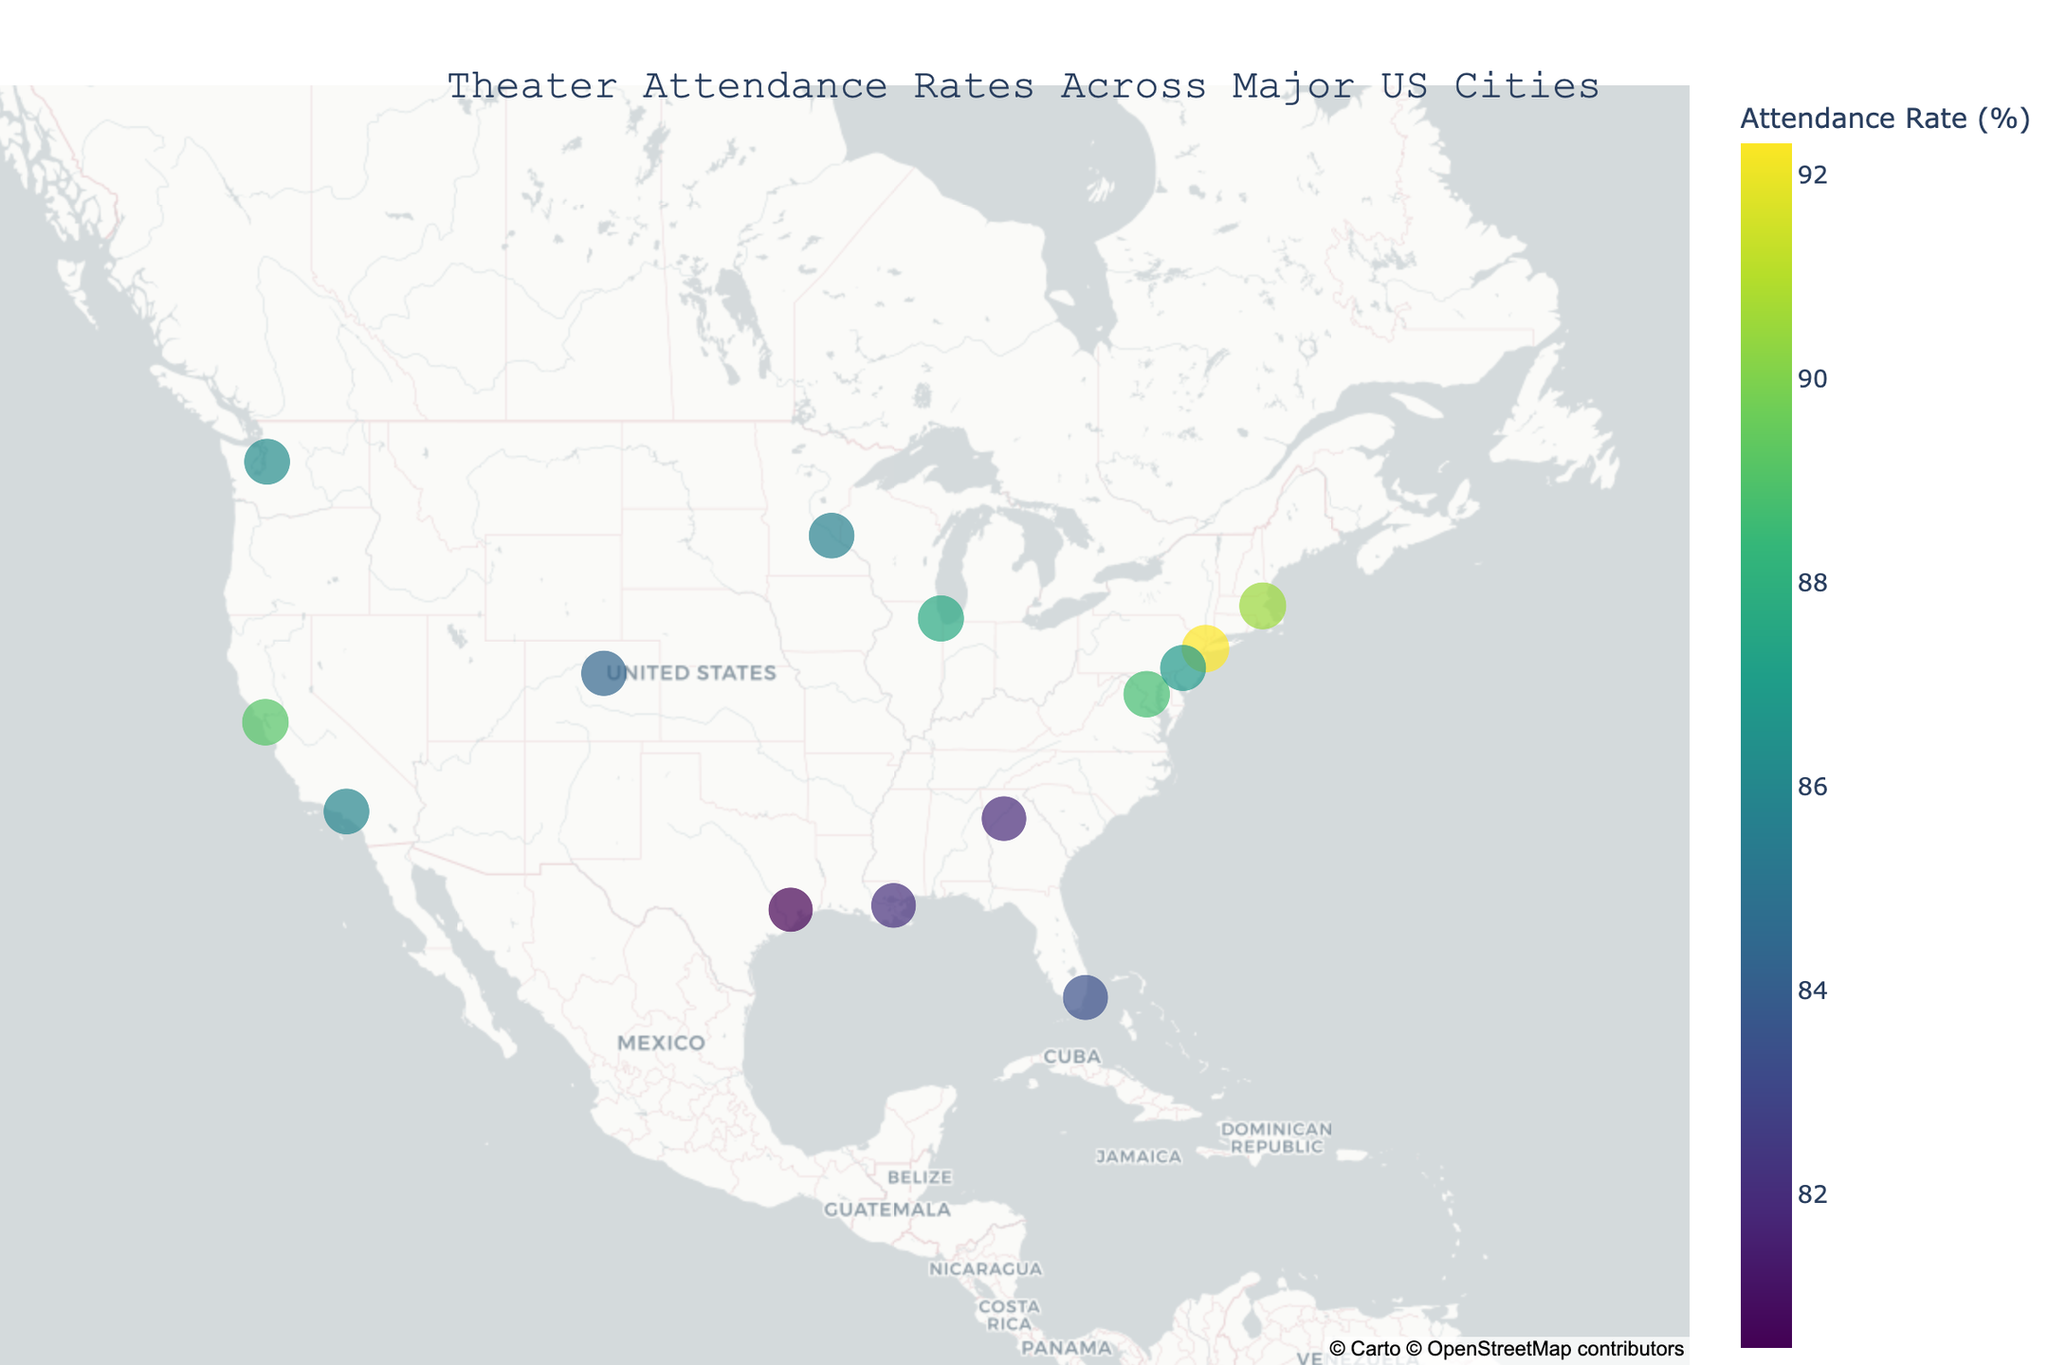What is the title of the plot? The title is located at the top of the plot and provides an overview of the data being visualized. In this case, it is "Theater Attendance Rates Across Major US Cities".
Answer: Theater Attendance Rates Across Major US Cities Which city has the highest theater attendance rate? Identify the city with the largest circle size and the highest value for theater attendance rate from the color gradient. According to the data, New York City has the highest rate at 92.3%.
Answer: New York City What is the theater attendance rate in Miami? Look at the circle representing Miami on the map. The hover information will show the theater attendance rate. From the data provided, Miami's theater attendance rate is listed as 83.4%.
Answer: 83.4% Which city has a higher theater attendance rate: Minneapolis or Denver? Compare the theater attendance rates directly. From the data, Minneapolis has an attendance rate of 85.7%, while Denver has a rate of 84.3%. Minneapolis has the higher rate.
Answer: Minneapolis How many cities have an attendance rate higher than 85%? Count the number of cities with theater attendance rates over 85% by examining the color gradient and hover data. The cities are New York City, Chicago, Los Angeles, San Francisco, Boston, Washington D.C., Seattle, Philadelphia, and Minneapolis. This gives a total of 9 cities.
Answer: 9 What is the average theater attendance rate of the cities displayed on the map? Add up all the theater attendance rates from the data and divide by the number of cities. The sum is 1,218.7, and there are 14 cities. So, the average is 1,218.7 / 14 = 87.0%.
Answer: 87.0% Which state is home to the city with the second highest theater attendance rate? Identify the city with the second highest attendance rate from the data. Boston has the second highest rate at 90.5%, and it is located in Massachusetts.
Answer: Massachusetts What is the difference in theater attendance rates between the highest and the lowest rate? Subtract the lowest rate from the highest rate. The highest rate is 92.3% (New York City) and the lowest is 80.5% (Houston). The difference is 92.3% - 80.5% = 11.8%.
Answer: 11.8% How many cities in California are shown on the map, and what are their attendance rates? Identify the cities in California: Los Angeles and San Francisco. Los Angeles has a rate of 85.9% and San Francisco has a rate of 89.1%.
Answer: 2; Los Angeles: 85.9%, San Francisco: 89.1% Which states have more than one city represented on the map? Identify the states with more than one city by reviewing the data. Only California (Los Angeles, San Francisco) has more than one city.
Answer: California 